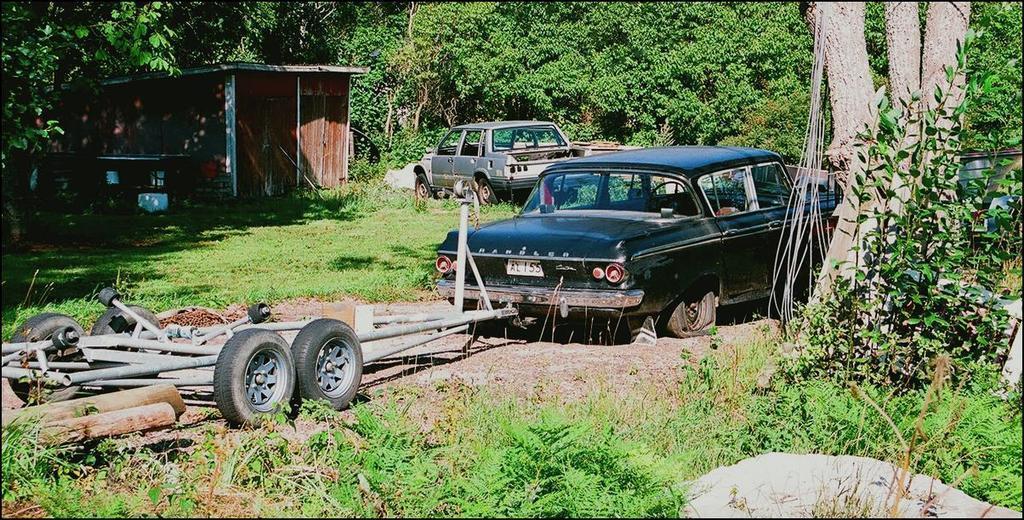How would you summarize this image in a sentence or two? In the image in the center we can see few vehicles,trees,tires,rods,sticks,grass etc. In the background we can see wooden house,trees,plants,grass etc. 